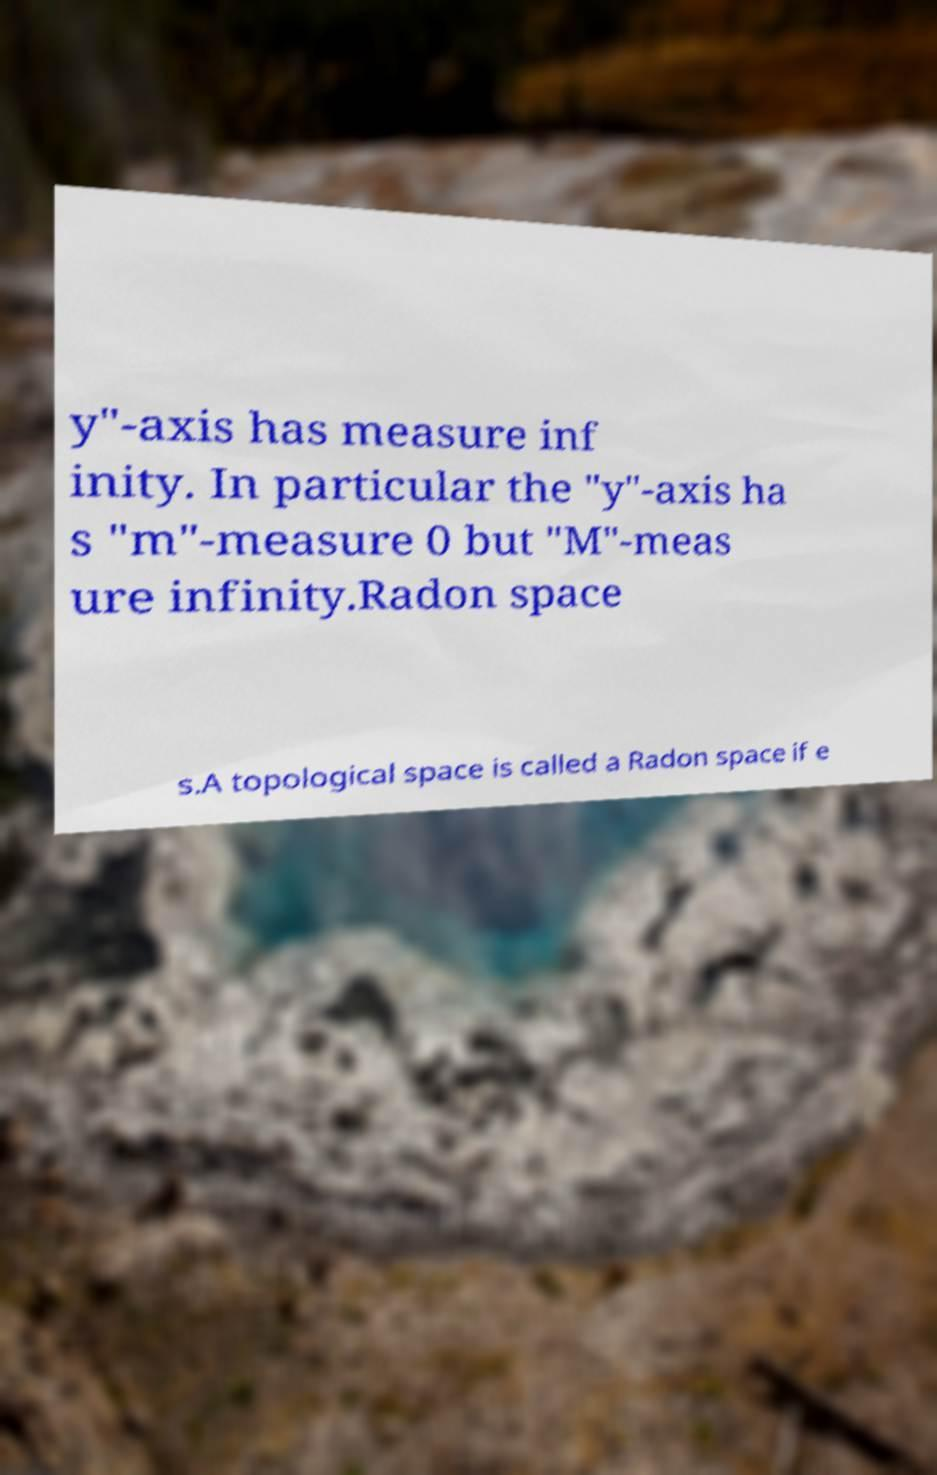For documentation purposes, I need the text within this image transcribed. Could you provide that? y"-axis has measure inf inity. In particular the "y"-axis ha s "m"-measure 0 but "M"-meas ure infinity.Radon space s.A topological space is called a Radon space if e 